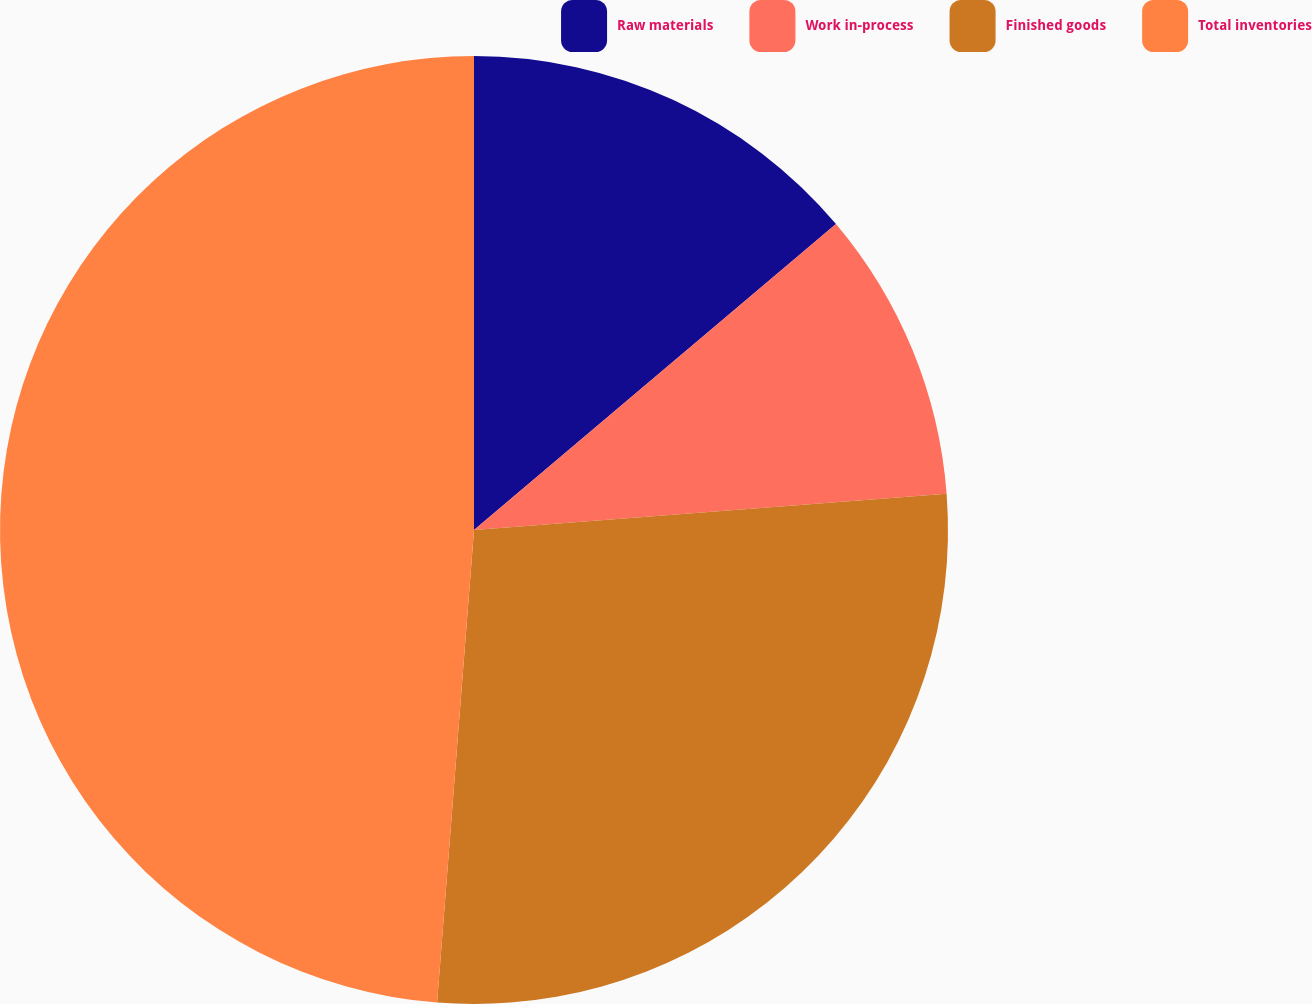<chart> <loc_0><loc_0><loc_500><loc_500><pie_chart><fcel>Raw materials<fcel>Work in-process<fcel>Finished goods<fcel>Total inventories<nl><fcel>13.83%<fcel>9.95%<fcel>27.46%<fcel>48.76%<nl></chart> 